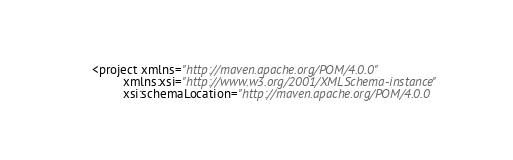<code> <loc_0><loc_0><loc_500><loc_500><_XML_><project xmlns="http://maven.apache.org/POM/4.0.0"
         xmlns:xsi="http://www.w3.org/2001/XMLSchema-instance"
         xsi:schemaLocation="http://maven.apache.org/POM/4.0.0</code> 